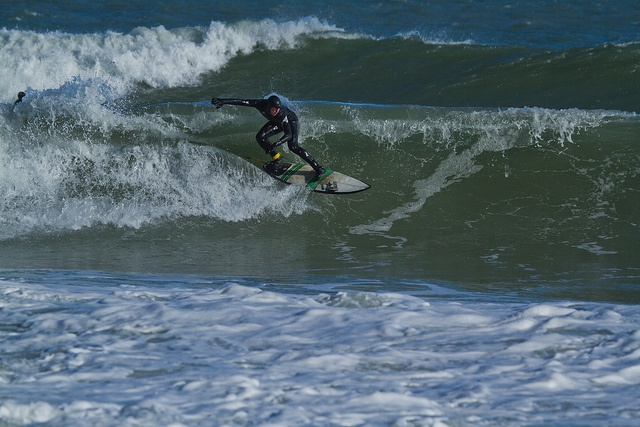Describe the objects in this image and their specific colors. I can see people in blue, black, and purple tones and surfboard in blue, black, gray, and darkgreen tones in this image. 